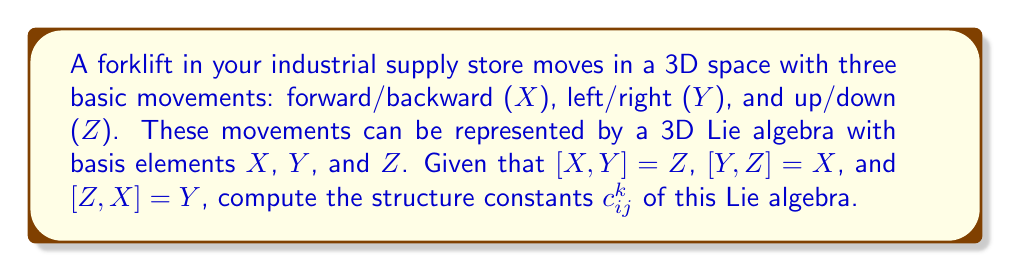Help me with this question. To compute the structure constants of a Lie algebra, we need to understand that for basis elements $e_i$, $e_j$, and $e_k$, the Lie bracket operation is defined as:

$$[e_i, e_j] = \sum_k c_{ij}^k e_k$$

where $c_{ij}^k$ are the structure constants.

In our case, we have:
1. $X = e_1$, $Y = e_2$, $Z = e_3$
2. $[X,Y] = Z$ implies $[e_1, e_2] = e_3$
3. $[Y,Z] = X$ implies $[e_2, e_3] = e_1$
4. $[Z,X] = Y$ implies $[e_3, e_1] = e_2$

Let's compute the structure constants:

1. For $[X,Y] = Z$:
   $c_{12}^3 = 1$, $c_{12}^1 = c_{12}^2 = 0$

2. For $[Y,Z] = X$:
   $c_{23}^1 = 1$, $c_{23}^2 = c_{23}^3 = 0$

3. For $[Z,X] = Y$:
   $c_{31}^2 = 1$, $c_{31}^1 = c_{31}^3 = 0$

4. Due to antisymmetry of the Lie bracket:
   $c_{21}^3 = -1$, $c_{32}^1 = -1$, $c_{13}^2 = -1$

5. All other structure constants are zero.

The complete set of non-zero structure constants is:
$$c_{12}^3 = -c_{21}^3 = 1$$
$$c_{23}^1 = -c_{32}^1 = 1$$
$$c_{31}^2 = -c_{13}^2 = 1$$
Answer: The non-zero structure constants are:
$$c_{12}^3 = -c_{21}^3 = 1$$
$$c_{23}^1 = -c_{32}^1 = 1$$
$$c_{31}^2 = -c_{13}^2 = 1$$
All other structure constants are zero. 